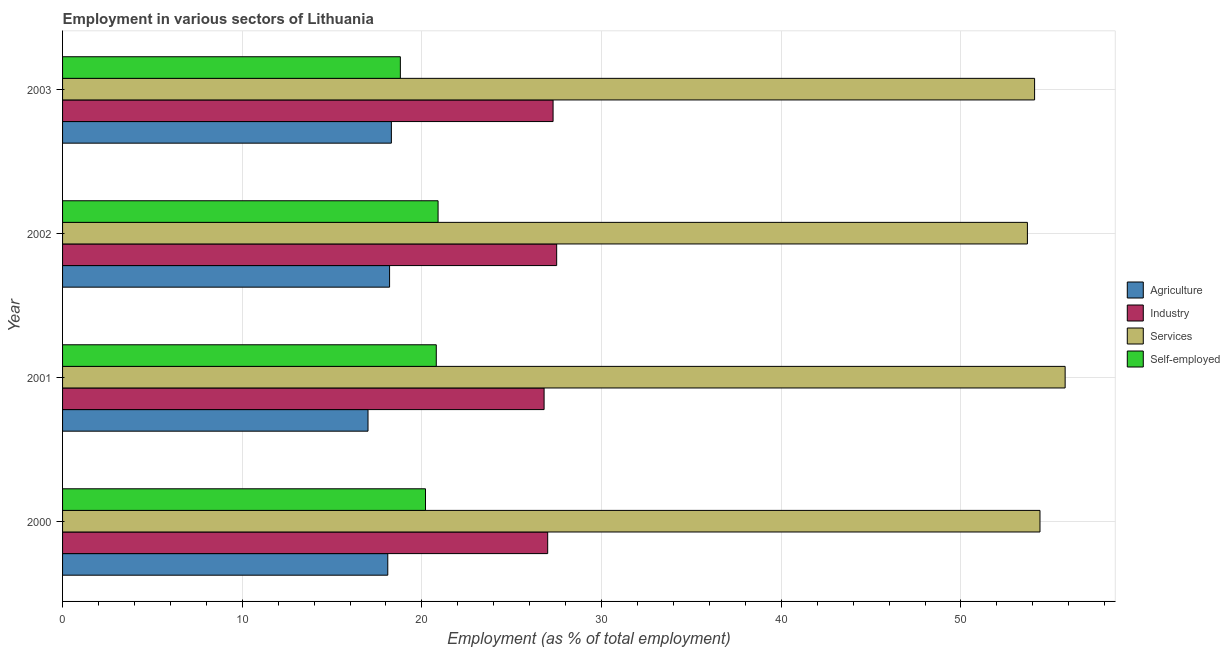Are the number of bars on each tick of the Y-axis equal?
Give a very brief answer. Yes. How many bars are there on the 1st tick from the top?
Make the answer very short. 4. What is the percentage of workers in agriculture in 2002?
Ensure brevity in your answer.  18.2. Across all years, what is the maximum percentage of self employed workers?
Give a very brief answer. 20.9. Across all years, what is the minimum percentage of workers in industry?
Provide a short and direct response. 26.8. In which year was the percentage of workers in agriculture minimum?
Your answer should be compact. 2001. What is the total percentage of workers in industry in the graph?
Make the answer very short. 108.6. What is the difference between the percentage of workers in services in 2000 and the percentage of workers in agriculture in 2001?
Offer a terse response. 37.4. What is the average percentage of workers in services per year?
Give a very brief answer. 54.5. In the year 2002, what is the difference between the percentage of workers in agriculture and percentage of workers in services?
Give a very brief answer. -35.5. In how many years, is the percentage of self employed workers greater than 6 %?
Your answer should be very brief. 4. In how many years, is the percentage of workers in industry greater than the average percentage of workers in industry taken over all years?
Provide a short and direct response. 2. Is it the case that in every year, the sum of the percentage of workers in agriculture and percentage of workers in industry is greater than the sum of percentage of workers in services and percentage of self employed workers?
Your answer should be very brief. No. What does the 4th bar from the top in 2001 represents?
Your response must be concise. Agriculture. What does the 1st bar from the bottom in 2001 represents?
Your response must be concise. Agriculture. Is it the case that in every year, the sum of the percentage of workers in agriculture and percentage of workers in industry is greater than the percentage of workers in services?
Your answer should be very brief. No. How many bars are there?
Keep it short and to the point. 16. Are all the bars in the graph horizontal?
Give a very brief answer. Yes. What is the difference between two consecutive major ticks on the X-axis?
Give a very brief answer. 10. Does the graph contain any zero values?
Give a very brief answer. No. Where does the legend appear in the graph?
Ensure brevity in your answer.  Center right. What is the title of the graph?
Your answer should be very brief. Employment in various sectors of Lithuania. What is the label or title of the X-axis?
Ensure brevity in your answer.  Employment (as % of total employment). What is the Employment (as % of total employment) of Agriculture in 2000?
Provide a succinct answer. 18.1. What is the Employment (as % of total employment) of Services in 2000?
Your answer should be compact. 54.4. What is the Employment (as % of total employment) of Self-employed in 2000?
Provide a succinct answer. 20.2. What is the Employment (as % of total employment) in Agriculture in 2001?
Provide a short and direct response. 17. What is the Employment (as % of total employment) of Industry in 2001?
Your answer should be very brief. 26.8. What is the Employment (as % of total employment) in Services in 2001?
Your answer should be very brief. 55.8. What is the Employment (as % of total employment) of Self-employed in 2001?
Your answer should be very brief. 20.8. What is the Employment (as % of total employment) in Agriculture in 2002?
Offer a very short reply. 18.2. What is the Employment (as % of total employment) in Industry in 2002?
Provide a short and direct response. 27.5. What is the Employment (as % of total employment) of Services in 2002?
Give a very brief answer. 53.7. What is the Employment (as % of total employment) of Self-employed in 2002?
Offer a very short reply. 20.9. What is the Employment (as % of total employment) in Agriculture in 2003?
Give a very brief answer. 18.3. What is the Employment (as % of total employment) in Industry in 2003?
Offer a terse response. 27.3. What is the Employment (as % of total employment) of Services in 2003?
Make the answer very short. 54.1. What is the Employment (as % of total employment) of Self-employed in 2003?
Give a very brief answer. 18.8. Across all years, what is the maximum Employment (as % of total employment) of Agriculture?
Give a very brief answer. 18.3. Across all years, what is the maximum Employment (as % of total employment) in Industry?
Offer a terse response. 27.5. Across all years, what is the maximum Employment (as % of total employment) of Services?
Provide a succinct answer. 55.8. Across all years, what is the maximum Employment (as % of total employment) in Self-employed?
Your response must be concise. 20.9. Across all years, what is the minimum Employment (as % of total employment) of Agriculture?
Provide a short and direct response. 17. Across all years, what is the minimum Employment (as % of total employment) of Industry?
Offer a very short reply. 26.8. Across all years, what is the minimum Employment (as % of total employment) in Services?
Ensure brevity in your answer.  53.7. Across all years, what is the minimum Employment (as % of total employment) in Self-employed?
Ensure brevity in your answer.  18.8. What is the total Employment (as % of total employment) in Agriculture in the graph?
Keep it short and to the point. 71.6. What is the total Employment (as % of total employment) in Industry in the graph?
Provide a short and direct response. 108.6. What is the total Employment (as % of total employment) in Services in the graph?
Your answer should be very brief. 218. What is the total Employment (as % of total employment) in Self-employed in the graph?
Make the answer very short. 80.7. What is the difference between the Employment (as % of total employment) of Services in 2000 and that in 2001?
Provide a short and direct response. -1.4. What is the difference between the Employment (as % of total employment) in Self-employed in 2000 and that in 2001?
Offer a very short reply. -0.6. What is the difference between the Employment (as % of total employment) in Agriculture in 2000 and that in 2002?
Make the answer very short. -0.1. What is the difference between the Employment (as % of total employment) in Industry in 2000 and that in 2002?
Your response must be concise. -0.5. What is the difference between the Employment (as % of total employment) of Services in 2000 and that in 2002?
Your response must be concise. 0.7. What is the difference between the Employment (as % of total employment) in Agriculture in 2000 and that in 2003?
Offer a very short reply. -0.2. What is the difference between the Employment (as % of total employment) in Services in 2000 and that in 2003?
Give a very brief answer. 0.3. What is the difference between the Employment (as % of total employment) of Self-employed in 2000 and that in 2003?
Your response must be concise. 1.4. What is the difference between the Employment (as % of total employment) in Industry in 2001 and that in 2002?
Offer a terse response. -0.7. What is the difference between the Employment (as % of total employment) of Self-employed in 2001 and that in 2002?
Ensure brevity in your answer.  -0.1. What is the difference between the Employment (as % of total employment) of Agriculture in 2001 and that in 2003?
Your answer should be compact. -1.3. What is the difference between the Employment (as % of total employment) in Industry in 2001 and that in 2003?
Make the answer very short. -0.5. What is the difference between the Employment (as % of total employment) of Self-employed in 2001 and that in 2003?
Ensure brevity in your answer.  2. What is the difference between the Employment (as % of total employment) in Industry in 2002 and that in 2003?
Your answer should be compact. 0.2. What is the difference between the Employment (as % of total employment) of Services in 2002 and that in 2003?
Offer a very short reply. -0.4. What is the difference between the Employment (as % of total employment) of Self-employed in 2002 and that in 2003?
Keep it short and to the point. 2.1. What is the difference between the Employment (as % of total employment) of Agriculture in 2000 and the Employment (as % of total employment) of Services in 2001?
Offer a terse response. -37.7. What is the difference between the Employment (as % of total employment) of Industry in 2000 and the Employment (as % of total employment) of Services in 2001?
Ensure brevity in your answer.  -28.8. What is the difference between the Employment (as % of total employment) in Industry in 2000 and the Employment (as % of total employment) in Self-employed in 2001?
Make the answer very short. 6.2. What is the difference between the Employment (as % of total employment) in Services in 2000 and the Employment (as % of total employment) in Self-employed in 2001?
Offer a terse response. 33.6. What is the difference between the Employment (as % of total employment) of Agriculture in 2000 and the Employment (as % of total employment) of Industry in 2002?
Ensure brevity in your answer.  -9.4. What is the difference between the Employment (as % of total employment) in Agriculture in 2000 and the Employment (as % of total employment) in Services in 2002?
Keep it short and to the point. -35.6. What is the difference between the Employment (as % of total employment) of Agriculture in 2000 and the Employment (as % of total employment) of Self-employed in 2002?
Your response must be concise. -2.8. What is the difference between the Employment (as % of total employment) of Industry in 2000 and the Employment (as % of total employment) of Services in 2002?
Provide a succinct answer. -26.7. What is the difference between the Employment (as % of total employment) in Services in 2000 and the Employment (as % of total employment) in Self-employed in 2002?
Give a very brief answer. 33.5. What is the difference between the Employment (as % of total employment) in Agriculture in 2000 and the Employment (as % of total employment) in Services in 2003?
Provide a succinct answer. -36. What is the difference between the Employment (as % of total employment) in Industry in 2000 and the Employment (as % of total employment) in Services in 2003?
Offer a terse response. -27.1. What is the difference between the Employment (as % of total employment) in Services in 2000 and the Employment (as % of total employment) in Self-employed in 2003?
Give a very brief answer. 35.6. What is the difference between the Employment (as % of total employment) in Agriculture in 2001 and the Employment (as % of total employment) in Services in 2002?
Your response must be concise. -36.7. What is the difference between the Employment (as % of total employment) of Industry in 2001 and the Employment (as % of total employment) of Services in 2002?
Offer a very short reply. -26.9. What is the difference between the Employment (as % of total employment) in Industry in 2001 and the Employment (as % of total employment) in Self-employed in 2002?
Offer a very short reply. 5.9. What is the difference between the Employment (as % of total employment) in Services in 2001 and the Employment (as % of total employment) in Self-employed in 2002?
Your answer should be very brief. 34.9. What is the difference between the Employment (as % of total employment) in Agriculture in 2001 and the Employment (as % of total employment) in Services in 2003?
Give a very brief answer. -37.1. What is the difference between the Employment (as % of total employment) of Industry in 2001 and the Employment (as % of total employment) of Services in 2003?
Offer a terse response. -27.3. What is the difference between the Employment (as % of total employment) of Services in 2001 and the Employment (as % of total employment) of Self-employed in 2003?
Make the answer very short. 37. What is the difference between the Employment (as % of total employment) of Agriculture in 2002 and the Employment (as % of total employment) of Services in 2003?
Your response must be concise. -35.9. What is the difference between the Employment (as % of total employment) in Industry in 2002 and the Employment (as % of total employment) in Services in 2003?
Ensure brevity in your answer.  -26.6. What is the difference between the Employment (as % of total employment) in Services in 2002 and the Employment (as % of total employment) in Self-employed in 2003?
Make the answer very short. 34.9. What is the average Employment (as % of total employment) in Agriculture per year?
Offer a terse response. 17.9. What is the average Employment (as % of total employment) in Industry per year?
Your answer should be very brief. 27.15. What is the average Employment (as % of total employment) in Services per year?
Keep it short and to the point. 54.5. What is the average Employment (as % of total employment) of Self-employed per year?
Offer a terse response. 20.18. In the year 2000, what is the difference between the Employment (as % of total employment) of Agriculture and Employment (as % of total employment) of Industry?
Your answer should be compact. -8.9. In the year 2000, what is the difference between the Employment (as % of total employment) in Agriculture and Employment (as % of total employment) in Services?
Ensure brevity in your answer.  -36.3. In the year 2000, what is the difference between the Employment (as % of total employment) in Agriculture and Employment (as % of total employment) in Self-employed?
Give a very brief answer. -2.1. In the year 2000, what is the difference between the Employment (as % of total employment) in Industry and Employment (as % of total employment) in Services?
Offer a very short reply. -27.4. In the year 2000, what is the difference between the Employment (as % of total employment) in Services and Employment (as % of total employment) in Self-employed?
Offer a terse response. 34.2. In the year 2001, what is the difference between the Employment (as % of total employment) of Agriculture and Employment (as % of total employment) of Industry?
Your answer should be very brief. -9.8. In the year 2001, what is the difference between the Employment (as % of total employment) of Agriculture and Employment (as % of total employment) of Services?
Make the answer very short. -38.8. In the year 2001, what is the difference between the Employment (as % of total employment) in Industry and Employment (as % of total employment) in Services?
Your answer should be very brief. -29. In the year 2001, what is the difference between the Employment (as % of total employment) of Industry and Employment (as % of total employment) of Self-employed?
Offer a very short reply. 6. In the year 2001, what is the difference between the Employment (as % of total employment) of Services and Employment (as % of total employment) of Self-employed?
Provide a succinct answer. 35. In the year 2002, what is the difference between the Employment (as % of total employment) of Agriculture and Employment (as % of total employment) of Services?
Ensure brevity in your answer.  -35.5. In the year 2002, what is the difference between the Employment (as % of total employment) of Agriculture and Employment (as % of total employment) of Self-employed?
Keep it short and to the point. -2.7. In the year 2002, what is the difference between the Employment (as % of total employment) of Industry and Employment (as % of total employment) of Services?
Ensure brevity in your answer.  -26.2. In the year 2002, what is the difference between the Employment (as % of total employment) in Industry and Employment (as % of total employment) in Self-employed?
Offer a very short reply. 6.6. In the year 2002, what is the difference between the Employment (as % of total employment) in Services and Employment (as % of total employment) in Self-employed?
Provide a short and direct response. 32.8. In the year 2003, what is the difference between the Employment (as % of total employment) in Agriculture and Employment (as % of total employment) in Services?
Make the answer very short. -35.8. In the year 2003, what is the difference between the Employment (as % of total employment) of Industry and Employment (as % of total employment) of Services?
Give a very brief answer. -26.8. In the year 2003, what is the difference between the Employment (as % of total employment) of Industry and Employment (as % of total employment) of Self-employed?
Your answer should be compact. 8.5. In the year 2003, what is the difference between the Employment (as % of total employment) of Services and Employment (as % of total employment) of Self-employed?
Provide a short and direct response. 35.3. What is the ratio of the Employment (as % of total employment) in Agriculture in 2000 to that in 2001?
Your answer should be very brief. 1.06. What is the ratio of the Employment (as % of total employment) in Industry in 2000 to that in 2001?
Keep it short and to the point. 1.01. What is the ratio of the Employment (as % of total employment) in Services in 2000 to that in 2001?
Offer a very short reply. 0.97. What is the ratio of the Employment (as % of total employment) of Self-employed in 2000 to that in 2001?
Keep it short and to the point. 0.97. What is the ratio of the Employment (as % of total employment) of Industry in 2000 to that in 2002?
Your answer should be compact. 0.98. What is the ratio of the Employment (as % of total employment) in Services in 2000 to that in 2002?
Your answer should be very brief. 1.01. What is the ratio of the Employment (as % of total employment) of Self-employed in 2000 to that in 2002?
Make the answer very short. 0.97. What is the ratio of the Employment (as % of total employment) in Self-employed in 2000 to that in 2003?
Provide a short and direct response. 1.07. What is the ratio of the Employment (as % of total employment) of Agriculture in 2001 to that in 2002?
Offer a very short reply. 0.93. What is the ratio of the Employment (as % of total employment) of Industry in 2001 to that in 2002?
Offer a very short reply. 0.97. What is the ratio of the Employment (as % of total employment) of Services in 2001 to that in 2002?
Offer a very short reply. 1.04. What is the ratio of the Employment (as % of total employment) in Agriculture in 2001 to that in 2003?
Keep it short and to the point. 0.93. What is the ratio of the Employment (as % of total employment) in Industry in 2001 to that in 2003?
Keep it short and to the point. 0.98. What is the ratio of the Employment (as % of total employment) in Services in 2001 to that in 2003?
Ensure brevity in your answer.  1.03. What is the ratio of the Employment (as % of total employment) of Self-employed in 2001 to that in 2003?
Make the answer very short. 1.11. What is the ratio of the Employment (as % of total employment) in Agriculture in 2002 to that in 2003?
Offer a terse response. 0.99. What is the ratio of the Employment (as % of total employment) in Industry in 2002 to that in 2003?
Your answer should be compact. 1.01. What is the ratio of the Employment (as % of total employment) of Services in 2002 to that in 2003?
Keep it short and to the point. 0.99. What is the ratio of the Employment (as % of total employment) in Self-employed in 2002 to that in 2003?
Give a very brief answer. 1.11. What is the difference between the highest and the second highest Employment (as % of total employment) of Industry?
Offer a terse response. 0.2. What is the difference between the highest and the second highest Employment (as % of total employment) of Self-employed?
Ensure brevity in your answer.  0.1. What is the difference between the highest and the lowest Employment (as % of total employment) of Industry?
Offer a very short reply. 0.7. What is the difference between the highest and the lowest Employment (as % of total employment) in Services?
Your answer should be compact. 2.1. 